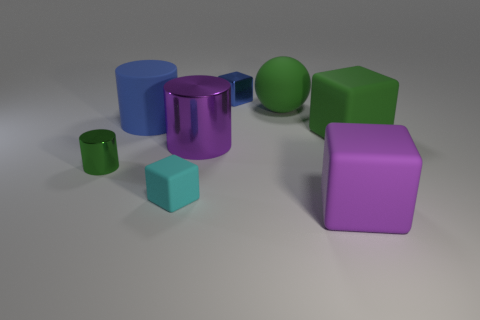Add 1 spheres. How many objects exist? 9 Subtract all spheres. How many objects are left? 7 Add 7 green cubes. How many green cubes exist? 8 Subtract 0 purple balls. How many objects are left? 8 Subtract all big matte balls. Subtract all big purple cubes. How many objects are left? 6 Add 3 big purple metal things. How many big purple metal things are left? 4 